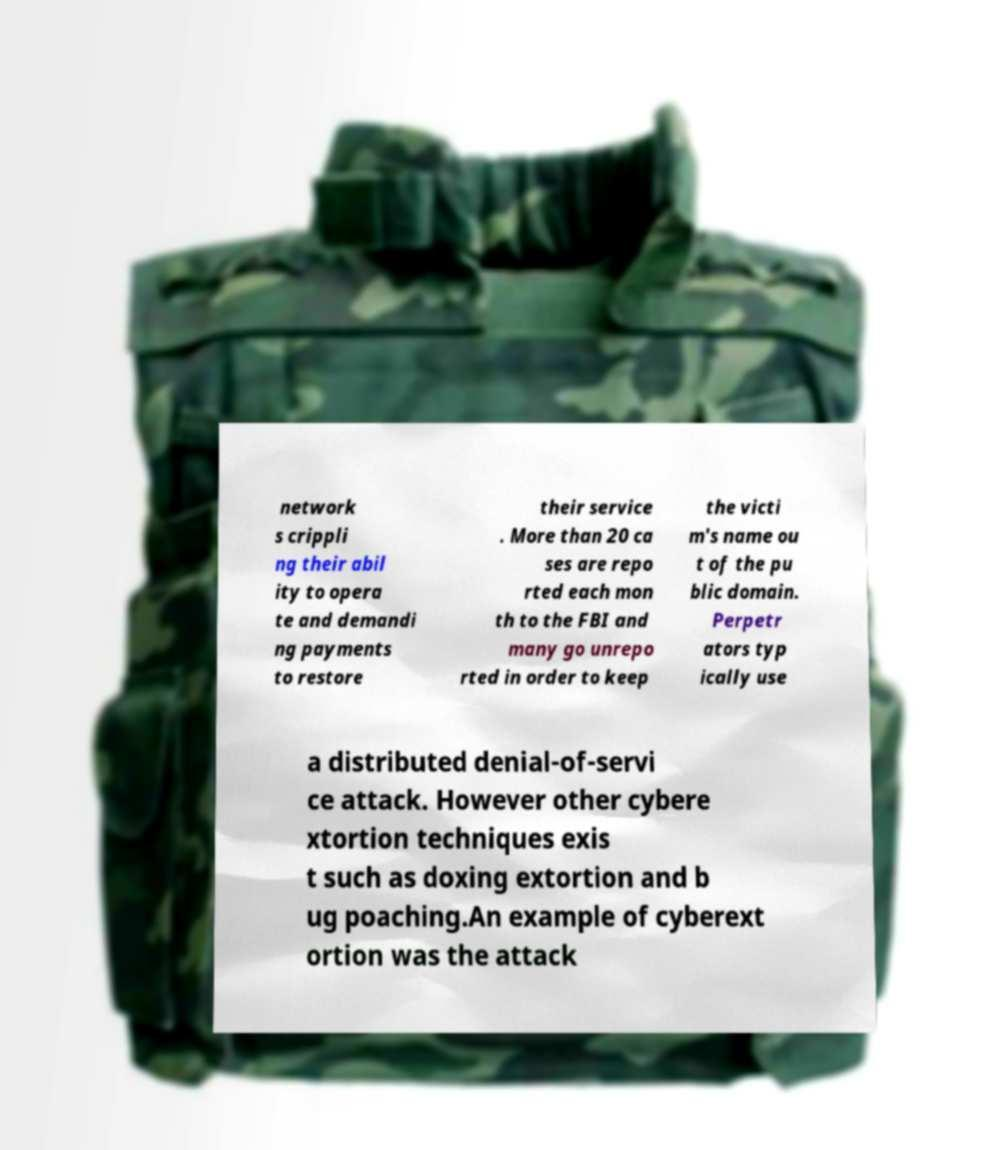Can you accurately transcribe the text from the provided image for me? network s crippli ng their abil ity to opera te and demandi ng payments to restore their service . More than 20 ca ses are repo rted each mon th to the FBI and many go unrepo rted in order to keep the victi m's name ou t of the pu blic domain. Perpetr ators typ ically use a distributed denial-of-servi ce attack. However other cybere xtortion techniques exis t such as doxing extortion and b ug poaching.An example of cyberext ortion was the attack 